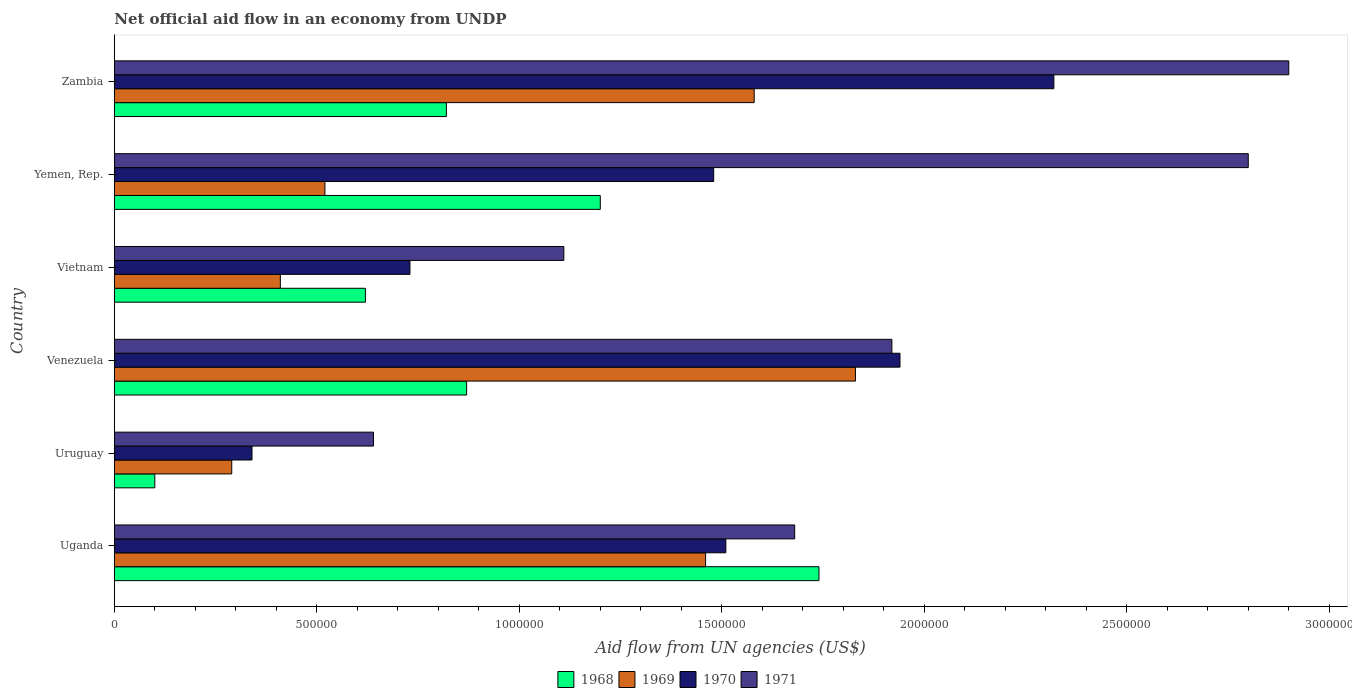How many different coloured bars are there?
Your answer should be very brief. 4. How many groups of bars are there?
Offer a very short reply. 6. Are the number of bars per tick equal to the number of legend labels?
Keep it short and to the point. Yes. Are the number of bars on each tick of the Y-axis equal?
Offer a terse response. Yes. How many bars are there on the 5th tick from the top?
Your response must be concise. 4. How many bars are there on the 3rd tick from the bottom?
Ensure brevity in your answer.  4. What is the label of the 6th group of bars from the top?
Your response must be concise. Uganda. What is the net official aid flow in 1968 in Uganda?
Your answer should be very brief. 1.74e+06. Across all countries, what is the maximum net official aid flow in 1968?
Offer a terse response. 1.74e+06. Across all countries, what is the minimum net official aid flow in 1969?
Provide a succinct answer. 2.90e+05. In which country was the net official aid flow in 1969 maximum?
Offer a terse response. Venezuela. In which country was the net official aid flow in 1970 minimum?
Make the answer very short. Uruguay. What is the total net official aid flow in 1969 in the graph?
Your answer should be very brief. 6.09e+06. What is the difference between the net official aid flow in 1968 in Zambia and the net official aid flow in 1969 in Uganda?
Provide a succinct answer. -6.40e+05. What is the average net official aid flow in 1969 per country?
Offer a very short reply. 1.02e+06. What is the difference between the net official aid flow in 1971 and net official aid flow in 1968 in Uganda?
Make the answer very short. -6.00e+04. In how many countries, is the net official aid flow in 1971 greater than 1700000 US$?
Your answer should be very brief. 3. What is the ratio of the net official aid flow in 1968 in Uganda to that in Vietnam?
Offer a terse response. 2.81. Is the net official aid flow in 1969 in Uruguay less than that in Vietnam?
Provide a short and direct response. Yes. Is the difference between the net official aid flow in 1971 in Uganda and Zambia greater than the difference between the net official aid flow in 1968 in Uganda and Zambia?
Ensure brevity in your answer.  No. What is the difference between the highest and the second highest net official aid flow in 1969?
Ensure brevity in your answer.  2.50e+05. What is the difference between the highest and the lowest net official aid flow in 1969?
Offer a very short reply. 1.54e+06. In how many countries, is the net official aid flow in 1970 greater than the average net official aid flow in 1970 taken over all countries?
Ensure brevity in your answer.  4. What does the 4th bar from the top in Venezuela represents?
Keep it short and to the point. 1968. What does the 4th bar from the bottom in Vietnam represents?
Your answer should be very brief. 1971. Is it the case that in every country, the sum of the net official aid flow in 1971 and net official aid flow in 1970 is greater than the net official aid flow in 1969?
Offer a very short reply. Yes. Are all the bars in the graph horizontal?
Give a very brief answer. Yes. What is the difference between two consecutive major ticks on the X-axis?
Keep it short and to the point. 5.00e+05. Does the graph contain grids?
Provide a succinct answer. No. What is the title of the graph?
Your answer should be very brief. Net official aid flow in an economy from UNDP. What is the label or title of the X-axis?
Make the answer very short. Aid flow from UN agencies (US$). What is the label or title of the Y-axis?
Provide a succinct answer. Country. What is the Aid flow from UN agencies (US$) in 1968 in Uganda?
Offer a very short reply. 1.74e+06. What is the Aid flow from UN agencies (US$) in 1969 in Uganda?
Keep it short and to the point. 1.46e+06. What is the Aid flow from UN agencies (US$) of 1970 in Uganda?
Offer a terse response. 1.51e+06. What is the Aid flow from UN agencies (US$) of 1971 in Uganda?
Offer a very short reply. 1.68e+06. What is the Aid flow from UN agencies (US$) in 1969 in Uruguay?
Your answer should be very brief. 2.90e+05. What is the Aid flow from UN agencies (US$) in 1971 in Uruguay?
Your answer should be very brief. 6.40e+05. What is the Aid flow from UN agencies (US$) in 1968 in Venezuela?
Make the answer very short. 8.70e+05. What is the Aid flow from UN agencies (US$) in 1969 in Venezuela?
Ensure brevity in your answer.  1.83e+06. What is the Aid flow from UN agencies (US$) in 1970 in Venezuela?
Keep it short and to the point. 1.94e+06. What is the Aid flow from UN agencies (US$) in 1971 in Venezuela?
Ensure brevity in your answer.  1.92e+06. What is the Aid flow from UN agencies (US$) of 1968 in Vietnam?
Your response must be concise. 6.20e+05. What is the Aid flow from UN agencies (US$) of 1970 in Vietnam?
Give a very brief answer. 7.30e+05. What is the Aid flow from UN agencies (US$) in 1971 in Vietnam?
Keep it short and to the point. 1.11e+06. What is the Aid flow from UN agencies (US$) of 1968 in Yemen, Rep.?
Keep it short and to the point. 1.20e+06. What is the Aid flow from UN agencies (US$) in 1969 in Yemen, Rep.?
Offer a very short reply. 5.20e+05. What is the Aid flow from UN agencies (US$) of 1970 in Yemen, Rep.?
Provide a succinct answer. 1.48e+06. What is the Aid flow from UN agencies (US$) in 1971 in Yemen, Rep.?
Make the answer very short. 2.80e+06. What is the Aid flow from UN agencies (US$) of 1968 in Zambia?
Your answer should be compact. 8.20e+05. What is the Aid flow from UN agencies (US$) of 1969 in Zambia?
Your response must be concise. 1.58e+06. What is the Aid flow from UN agencies (US$) of 1970 in Zambia?
Provide a succinct answer. 2.32e+06. What is the Aid flow from UN agencies (US$) in 1971 in Zambia?
Give a very brief answer. 2.90e+06. Across all countries, what is the maximum Aid flow from UN agencies (US$) of 1968?
Offer a very short reply. 1.74e+06. Across all countries, what is the maximum Aid flow from UN agencies (US$) of 1969?
Offer a terse response. 1.83e+06. Across all countries, what is the maximum Aid flow from UN agencies (US$) in 1970?
Give a very brief answer. 2.32e+06. Across all countries, what is the maximum Aid flow from UN agencies (US$) in 1971?
Provide a short and direct response. 2.90e+06. Across all countries, what is the minimum Aid flow from UN agencies (US$) in 1968?
Your response must be concise. 1.00e+05. Across all countries, what is the minimum Aid flow from UN agencies (US$) in 1970?
Ensure brevity in your answer.  3.40e+05. Across all countries, what is the minimum Aid flow from UN agencies (US$) in 1971?
Keep it short and to the point. 6.40e+05. What is the total Aid flow from UN agencies (US$) of 1968 in the graph?
Your answer should be compact. 5.35e+06. What is the total Aid flow from UN agencies (US$) of 1969 in the graph?
Give a very brief answer. 6.09e+06. What is the total Aid flow from UN agencies (US$) in 1970 in the graph?
Make the answer very short. 8.32e+06. What is the total Aid flow from UN agencies (US$) in 1971 in the graph?
Your answer should be very brief. 1.10e+07. What is the difference between the Aid flow from UN agencies (US$) in 1968 in Uganda and that in Uruguay?
Your answer should be compact. 1.64e+06. What is the difference between the Aid flow from UN agencies (US$) of 1969 in Uganda and that in Uruguay?
Give a very brief answer. 1.17e+06. What is the difference between the Aid flow from UN agencies (US$) of 1970 in Uganda and that in Uruguay?
Your answer should be compact. 1.17e+06. What is the difference between the Aid flow from UN agencies (US$) in 1971 in Uganda and that in Uruguay?
Make the answer very short. 1.04e+06. What is the difference between the Aid flow from UN agencies (US$) of 1968 in Uganda and that in Venezuela?
Your response must be concise. 8.70e+05. What is the difference between the Aid flow from UN agencies (US$) in 1969 in Uganda and that in Venezuela?
Your answer should be compact. -3.70e+05. What is the difference between the Aid flow from UN agencies (US$) in 1970 in Uganda and that in Venezuela?
Give a very brief answer. -4.30e+05. What is the difference between the Aid flow from UN agencies (US$) of 1971 in Uganda and that in Venezuela?
Make the answer very short. -2.40e+05. What is the difference between the Aid flow from UN agencies (US$) of 1968 in Uganda and that in Vietnam?
Offer a very short reply. 1.12e+06. What is the difference between the Aid flow from UN agencies (US$) in 1969 in Uganda and that in Vietnam?
Offer a terse response. 1.05e+06. What is the difference between the Aid flow from UN agencies (US$) in 1970 in Uganda and that in Vietnam?
Provide a succinct answer. 7.80e+05. What is the difference between the Aid flow from UN agencies (US$) of 1971 in Uganda and that in Vietnam?
Your response must be concise. 5.70e+05. What is the difference between the Aid flow from UN agencies (US$) of 1968 in Uganda and that in Yemen, Rep.?
Offer a terse response. 5.40e+05. What is the difference between the Aid flow from UN agencies (US$) in 1969 in Uganda and that in Yemen, Rep.?
Your response must be concise. 9.40e+05. What is the difference between the Aid flow from UN agencies (US$) in 1971 in Uganda and that in Yemen, Rep.?
Your response must be concise. -1.12e+06. What is the difference between the Aid flow from UN agencies (US$) of 1968 in Uganda and that in Zambia?
Offer a very short reply. 9.20e+05. What is the difference between the Aid flow from UN agencies (US$) in 1969 in Uganda and that in Zambia?
Offer a very short reply. -1.20e+05. What is the difference between the Aid flow from UN agencies (US$) of 1970 in Uganda and that in Zambia?
Your answer should be compact. -8.10e+05. What is the difference between the Aid flow from UN agencies (US$) in 1971 in Uganda and that in Zambia?
Your answer should be very brief. -1.22e+06. What is the difference between the Aid flow from UN agencies (US$) in 1968 in Uruguay and that in Venezuela?
Ensure brevity in your answer.  -7.70e+05. What is the difference between the Aid flow from UN agencies (US$) of 1969 in Uruguay and that in Venezuela?
Your answer should be very brief. -1.54e+06. What is the difference between the Aid flow from UN agencies (US$) of 1970 in Uruguay and that in Venezuela?
Offer a terse response. -1.60e+06. What is the difference between the Aid flow from UN agencies (US$) of 1971 in Uruguay and that in Venezuela?
Provide a short and direct response. -1.28e+06. What is the difference between the Aid flow from UN agencies (US$) of 1968 in Uruguay and that in Vietnam?
Your answer should be very brief. -5.20e+05. What is the difference between the Aid flow from UN agencies (US$) in 1970 in Uruguay and that in Vietnam?
Your answer should be very brief. -3.90e+05. What is the difference between the Aid flow from UN agencies (US$) in 1971 in Uruguay and that in Vietnam?
Provide a succinct answer. -4.70e+05. What is the difference between the Aid flow from UN agencies (US$) in 1968 in Uruguay and that in Yemen, Rep.?
Give a very brief answer. -1.10e+06. What is the difference between the Aid flow from UN agencies (US$) of 1970 in Uruguay and that in Yemen, Rep.?
Your answer should be very brief. -1.14e+06. What is the difference between the Aid flow from UN agencies (US$) of 1971 in Uruguay and that in Yemen, Rep.?
Your answer should be compact. -2.16e+06. What is the difference between the Aid flow from UN agencies (US$) of 1968 in Uruguay and that in Zambia?
Keep it short and to the point. -7.20e+05. What is the difference between the Aid flow from UN agencies (US$) in 1969 in Uruguay and that in Zambia?
Offer a terse response. -1.29e+06. What is the difference between the Aid flow from UN agencies (US$) in 1970 in Uruguay and that in Zambia?
Offer a very short reply. -1.98e+06. What is the difference between the Aid flow from UN agencies (US$) in 1971 in Uruguay and that in Zambia?
Provide a short and direct response. -2.26e+06. What is the difference between the Aid flow from UN agencies (US$) in 1968 in Venezuela and that in Vietnam?
Your answer should be very brief. 2.50e+05. What is the difference between the Aid flow from UN agencies (US$) of 1969 in Venezuela and that in Vietnam?
Give a very brief answer. 1.42e+06. What is the difference between the Aid flow from UN agencies (US$) in 1970 in Venezuela and that in Vietnam?
Make the answer very short. 1.21e+06. What is the difference between the Aid flow from UN agencies (US$) in 1971 in Venezuela and that in Vietnam?
Keep it short and to the point. 8.10e+05. What is the difference between the Aid flow from UN agencies (US$) in 1968 in Venezuela and that in Yemen, Rep.?
Ensure brevity in your answer.  -3.30e+05. What is the difference between the Aid flow from UN agencies (US$) of 1969 in Venezuela and that in Yemen, Rep.?
Your response must be concise. 1.31e+06. What is the difference between the Aid flow from UN agencies (US$) in 1971 in Venezuela and that in Yemen, Rep.?
Provide a short and direct response. -8.80e+05. What is the difference between the Aid flow from UN agencies (US$) of 1968 in Venezuela and that in Zambia?
Offer a terse response. 5.00e+04. What is the difference between the Aid flow from UN agencies (US$) in 1969 in Venezuela and that in Zambia?
Your response must be concise. 2.50e+05. What is the difference between the Aid flow from UN agencies (US$) in 1970 in Venezuela and that in Zambia?
Your answer should be compact. -3.80e+05. What is the difference between the Aid flow from UN agencies (US$) of 1971 in Venezuela and that in Zambia?
Ensure brevity in your answer.  -9.80e+05. What is the difference between the Aid flow from UN agencies (US$) of 1968 in Vietnam and that in Yemen, Rep.?
Your answer should be compact. -5.80e+05. What is the difference between the Aid flow from UN agencies (US$) in 1970 in Vietnam and that in Yemen, Rep.?
Your answer should be compact. -7.50e+05. What is the difference between the Aid flow from UN agencies (US$) of 1971 in Vietnam and that in Yemen, Rep.?
Ensure brevity in your answer.  -1.69e+06. What is the difference between the Aid flow from UN agencies (US$) in 1968 in Vietnam and that in Zambia?
Give a very brief answer. -2.00e+05. What is the difference between the Aid flow from UN agencies (US$) in 1969 in Vietnam and that in Zambia?
Provide a short and direct response. -1.17e+06. What is the difference between the Aid flow from UN agencies (US$) in 1970 in Vietnam and that in Zambia?
Your answer should be very brief. -1.59e+06. What is the difference between the Aid flow from UN agencies (US$) of 1971 in Vietnam and that in Zambia?
Offer a very short reply. -1.79e+06. What is the difference between the Aid flow from UN agencies (US$) in 1969 in Yemen, Rep. and that in Zambia?
Provide a short and direct response. -1.06e+06. What is the difference between the Aid flow from UN agencies (US$) of 1970 in Yemen, Rep. and that in Zambia?
Keep it short and to the point. -8.40e+05. What is the difference between the Aid flow from UN agencies (US$) in 1968 in Uganda and the Aid flow from UN agencies (US$) in 1969 in Uruguay?
Offer a terse response. 1.45e+06. What is the difference between the Aid flow from UN agencies (US$) of 1968 in Uganda and the Aid flow from UN agencies (US$) of 1970 in Uruguay?
Offer a terse response. 1.40e+06. What is the difference between the Aid flow from UN agencies (US$) in 1968 in Uganda and the Aid flow from UN agencies (US$) in 1971 in Uruguay?
Keep it short and to the point. 1.10e+06. What is the difference between the Aid flow from UN agencies (US$) in 1969 in Uganda and the Aid flow from UN agencies (US$) in 1970 in Uruguay?
Provide a short and direct response. 1.12e+06. What is the difference between the Aid flow from UN agencies (US$) in 1969 in Uganda and the Aid flow from UN agencies (US$) in 1971 in Uruguay?
Offer a terse response. 8.20e+05. What is the difference between the Aid flow from UN agencies (US$) in 1970 in Uganda and the Aid flow from UN agencies (US$) in 1971 in Uruguay?
Your answer should be very brief. 8.70e+05. What is the difference between the Aid flow from UN agencies (US$) of 1968 in Uganda and the Aid flow from UN agencies (US$) of 1969 in Venezuela?
Make the answer very short. -9.00e+04. What is the difference between the Aid flow from UN agencies (US$) of 1968 in Uganda and the Aid flow from UN agencies (US$) of 1970 in Venezuela?
Your response must be concise. -2.00e+05. What is the difference between the Aid flow from UN agencies (US$) of 1968 in Uganda and the Aid flow from UN agencies (US$) of 1971 in Venezuela?
Keep it short and to the point. -1.80e+05. What is the difference between the Aid flow from UN agencies (US$) of 1969 in Uganda and the Aid flow from UN agencies (US$) of 1970 in Venezuela?
Provide a succinct answer. -4.80e+05. What is the difference between the Aid flow from UN agencies (US$) in 1969 in Uganda and the Aid flow from UN agencies (US$) in 1971 in Venezuela?
Your answer should be very brief. -4.60e+05. What is the difference between the Aid flow from UN agencies (US$) of 1970 in Uganda and the Aid flow from UN agencies (US$) of 1971 in Venezuela?
Make the answer very short. -4.10e+05. What is the difference between the Aid flow from UN agencies (US$) in 1968 in Uganda and the Aid flow from UN agencies (US$) in 1969 in Vietnam?
Provide a succinct answer. 1.33e+06. What is the difference between the Aid flow from UN agencies (US$) of 1968 in Uganda and the Aid flow from UN agencies (US$) of 1970 in Vietnam?
Your answer should be compact. 1.01e+06. What is the difference between the Aid flow from UN agencies (US$) in 1968 in Uganda and the Aid flow from UN agencies (US$) in 1971 in Vietnam?
Your response must be concise. 6.30e+05. What is the difference between the Aid flow from UN agencies (US$) in 1969 in Uganda and the Aid flow from UN agencies (US$) in 1970 in Vietnam?
Provide a succinct answer. 7.30e+05. What is the difference between the Aid flow from UN agencies (US$) in 1969 in Uganda and the Aid flow from UN agencies (US$) in 1971 in Vietnam?
Keep it short and to the point. 3.50e+05. What is the difference between the Aid flow from UN agencies (US$) of 1968 in Uganda and the Aid flow from UN agencies (US$) of 1969 in Yemen, Rep.?
Ensure brevity in your answer.  1.22e+06. What is the difference between the Aid flow from UN agencies (US$) in 1968 in Uganda and the Aid flow from UN agencies (US$) in 1971 in Yemen, Rep.?
Offer a terse response. -1.06e+06. What is the difference between the Aid flow from UN agencies (US$) of 1969 in Uganda and the Aid flow from UN agencies (US$) of 1971 in Yemen, Rep.?
Provide a short and direct response. -1.34e+06. What is the difference between the Aid flow from UN agencies (US$) of 1970 in Uganda and the Aid flow from UN agencies (US$) of 1971 in Yemen, Rep.?
Make the answer very short. -1.29e+06. What is the difference between the Aid flow from UN agencies (US$) in 1968 in Uganda and the Aid flow from UN agencies (US$) in 1969 in Zambia?
Offer a very short reply. 1.60e+05. What is the difference between the Aid flow from UN agencies (US$) of 1968 in Uganda and the Aid flow from UN agencies (US$) of 1970 in Zambia?
Offer a very short reply. -5.80e+05. What is the difference between the Aid flow from UN agencies (US$) in 1968 in Uganda and the Aid flow from UN agencies (US$) in 1971 in Zambia?
Give a very brief answer. -1.16e+06. What is the difference between the Aid flow from UN agencies (US$) in 1969 in Uganda and the Aid flow from UN agencies (US$) in 1970 in Zambia?
Offer a terse response. -8.60e+05. What is the difference between the Aid flow from UN agencies (US$) of 1969 in Uganda and the Aid flow from UN agencies (US$) of 1971 in Zambia?
Your answer should be very brief. -1.44e+06. What is the difference between the Aid flow from UN agencies (US$) in 1970 in Uganda and the Aid flow from UN agencies (US$) in 1971 in Zambia?
Your answer should be compact. -1.39e+06. What is the difference between the Aid flow from UN agencies (US$) in 1968 in Uruguay and the Aid flow from UN agencies (US$) in 1969 in Venezuela?
Offer a very short reply. -1.73e+06. What is the difference between the Aid flow from UN agencies (US$) of 1968 in Uruguay and the Aid flow from UN agencies (US$) of 1970 in Venezuela?
Offer a terse response. -1.84e+06. What is the difference between the Aid flow from UN agencies (US$) of 1968 in Uruguay and the Aid flow from UN agencies (US$) of 1971 in Venezuela?
Offer a very short reply. -1.82e+06. What is the difference between the Aid flow from UN agencies (US$) in 1969 in Uruguay and the Aid flow from UN agencies (US$) in 1970 in Venezuela?
Make the answer very short. -1.65e+06. What is the difference between the Aid flow from UN agencies (US$) of 1969 in Uruguay and the Aid flow from UN agencies (US$) of 1971 in Venezuela?
Provide a short and direct response. -1.63e+06. What is the difference between the Aid flow from UN agencies (US$) of 1970 in Uruguay and the Aid flow from UN agencies (US$) of 1971 in Venezuela?
Provide a succinct answer. -1.58e+06. What is the difference between the Aid flow from UN agencies (US$) of 1968 in Uruguay and the Aid flow from UN agencies (US$) of 1969 in Vietnam?
Your response must be concise. -3.10e+05. What is the difference between the Aid flow from UN agencies (US$) in 1968 in Uruguay and the Aid flow from UN agencies (US$) in 1970 in Vietnam?
Give a very brief answer. -6.30e+05. What is the difference between the Aid flow from UN agencies (US$) in 1968 in Uruguay and the Aid flow from UN agencies (US$) in 1971 in Vietnam?
Ensure brevity in your answer.  -1.01e+06. What is the difference between the Aid flow from UN agencies (US$) of 1969 in Uruguay and the Aid flow from UN agencies (US$) of 1970 in Vietnam?
Ensure brevity in your answer.  -4.40e+05. What is the difference between the Aid flow from UN agencies (US$) of 1969 in Uruguay and the Aid flow from UN agencies (US$) of 1971 in Vietnam?
Your answer should be compact. -8.20e+05. What is the difference between the Aid flow from UN agencies (US$) in 1970 in Uruguay and the Aid flow from UN agencies (US$) in 1971 in Vietnam?
Give a very brief answer. -7.70e+05. What is the difference between the Aid flow from UN agencies (US$) of 1968 in Uruguay and the Aid flow from UN agencies (US$) of 1969 in Yemen, Rep.?
Make the answer very short. -4.20e+05. What is the difference between the Aid flow from UN agencies (US$) of 1968 in Uruguay and the Aid flow from UN agencies (US$) of 1970 in Yemen, Rep.?
Keep it short and to the point. -1.38e+06. What is the difference between the Aid flow from UN agencies (US$) of 1968 in Uruguay and the Aid flow from UN agencies (US$) of 1971 in Yemen, Rep.?
Offer a terse response. -2.70e+06. What is the difference between the Aid flow from UN agencies (US$) in 1969 in Uruguay and the Aid flow from UN agencies (US$) in 1970 in Yemen, Rep.?
Keep it short and to the point. -1.19e+06. What is the difference between the Aid flow from UN agencies (US$) of 1969 in Uruguay and the Aid flow from UN agencies (US$) of 1971 in Yemen, Rep.?
Give a very brief answer. -2.51e+06. What is the difference between the Aid flow from UN agencies (US$) of 1970 in Uruguay and the Aid flow from UN agencies (US$) of 1971 in Yemen, Rep.?
Offer a very short reply. -2.46e+06. What is the difference between the Aid flow from UN agencies (US$) in 1968 in Uruguay and the Aid flow from UN agencies (US$) in 1969 in Zambia?
Keep it short and to the point. -1.48e+06. What is the difference between the Aid flow from UN agencies (US$) of 1968 in Uruguay and the Aid flow from UN agencies (US$) of 1970 in Zambia?
Give a very brief answer. -2.22e+06. What is the difference between the Aid flow from UN agencies (US$) in 1968 in Uruguay and the Aid flow from UN agencies (US$) in 1971 in Zambia?
Your response must be concise. -2.80e+06. What is the difference between the Aid flow from UN agencies (US$) of 1969 in Uruguay and the Aid flow from UN agencies (US$) of 1970 in Zambia?
Provide a short and direct response. -2.03e+06. What is the difference between the Aid flow from UN agencies (US$) of 1969 in Uruguay and the Aid flow from UN agencies (US$) of 1971 in Zambia?
Make the answer very short. -2.61e+06. What is the difference between the Aid flow from UN agencies (US$) in 1970 in Uruguay and the Aid flow from UN agencies (US$) in 1971 in Zambia?
Make the answer very short. -2.56e+06. What is the difference between the Aid flow from UN agencies (US$) of 1968 in Venezuela and the Aid flow from UN agencies (US$) of 1970 in Vietnam?
Make the answer very short. 1.40e+05. What is the difference between the Aid flow from UN agencies (US$) in 1968 in Venezuela and the Aid flow from UN agencies (US$) in 1971 in Vietnam?
Give a very brief answer. -2.40e+05. What is the difference between the Aid flow from UN agencies (US$) of 1969 in Venezuela and the Aid flow from UN agencies (US$) of 1970 in Vietnam?
Your answer should be compact. 1.10e+06. What is the difference between the Aid flow from UN agencies (US$) of 1969 in Venezuela and the Aid flow from UN agencies (US$) of 1971 in Vietnam?
Provide a short and direct response. 7.20e+05. What is the difference between the Aid flow from UN agencies (US$) of 1970 in Venezuela and the Aid flow from UN agencies (US$) of 1971 in Vietnam?
Keep it short and to the point. 8.30e+05. What is the difference between the Aid flow from UN agencies (US$) of 1968 in Venezuela and the Aid flow from UN agencies (US$) of 1969 in Yemen, Rep.?
Your answer should be very brief. 3.50e+05. What is the difference between the Aid flow from UN agencies (US$) of 1968 in Venezuela and the Aid flow from UN agencies (US$) of 1970 in Yemen, Rep.?
Make the answer very short. -6.10e+05. What is the difference between the Aid flow from UN agencies (US$) of 1968 in Venezuela and the Aid flow from UN agencies (US$) of 1971 in Yemen, Rep.?
Offer a terse response. -1.93e+06. What is the difference between the Aid flow from UN agencies (US$) of 1969 in Venezuela and the Aid flow from UN agencies (US$) of 1970 in Yemen, Rep.?
Offer a very short reply. 3.50e+05. What is the difference between the Aid flow from UN agencies (US$) in 1969 in Venezuela and the Aid flow from UN agencies (US$) in 1971 in Yemen, Rep.?
Your response must be concise. -9.70e+05. What is the difference between the Aid flow from UN agencies (US$) of 1970 in Venezuela and the Aid flow from UN agencies (US$) of 1971 in Yemen, Rep.?
Keep it short and to the point. -8.60e+05. What is the difference between the Aid flow from UN agencies (US$) of 1968 in Venezuela and the Aid flow from UN agencies (US$) of 1969 in Zambia?
Give a very brief answer. -7.10e+05. What is the difference between the Aid flow from UN agencies (US$) of 1968 in Venezuela and the Aid flow from UN agencies (US$) of 1970 in Zambia?
Provide a succinct answer. -1.45e+06. What is the difference between the Aid flow from UN agencies (US$) of 1968 in Venezuela and the Aid flow from UN agencies (US$) of 1971 in Zambia?
Offer a terse response. -2.03e+06. What is the difference between the Aid flow from UN agencies (US$) in 1969 in Venezuela and the Aid flow from UN agencies (US$) in 1970 in Zambia?
Offer a terse response. -4.90e+05. What is the difference between the Aid flow from UN agencies (US$) in 1969 in Venezuela and the Aid flow from UN agencies (US$) in 1971 in Zambia?
Make the answer very short. -1.07e+06. What is the difference between the Aid flow from UN agencies (US$) of 1970 in Venezuela and the Aid flow from UN agencies (US$) of 1971 in Zambia?
Offer a very short reply. -9.60e+05. What is the difference between the Aid flow from UN agencies (US$) of 1968 in Vietnam and the Aid flow from UN agencies (US$) of 1969 in Yemen, Rep.?
Your answer should be compact. 1.00e+05. What is the difference between the Aid flow from UN agencies (US$) of 1968 in Vietnam and the Aid flow from UN agencies (US$) of 1970 in Yemen, Rep.?
Ensure brevity in your answer.  -8.60e+05. What is the difference between the Aid flow from UN agencies (US$) in 1968 in Vietnam and the Aid flow from UN agencies (US$) in 1971 in Yemen, Rep.?
Offer a terse response. -2.18e+06. What is the difference between the Aid flow from UN agencies (US$) of 1969 in Vietnam and the Aid flow from UN agencies (US$) of 1970 in Yemen, Rep.?
Give a very brief answer. -1.07e+06. What is the difference between the Aid flow from UN agencies (US$) in 1969 in Vietnam and the Aid flow from UN agencies (US$) in 1971 in Yemen, Rep.?
Provide a short and direct response. -2.39e+06. What is the difference between the Aid flow from UN agencies (US$) in 1970 in Vietnam and the Aid flow from UN agencies (US$) in 1971 in Yemen, Rep.?
Offer a terse response. -2.07e+06. What is the difference between the Aid flow from UN agencies (US$) of 1968 in Vietnam and the Aid flow from UN agencies (US$) of 1969 in Zambia?
Offer a very short reply. -9.60e+05. What is the difference between the Aid flow from UN agencies (US$) in 1968 in Vietnam and the Aid flow from UN agencies (US$) in 1970 in Zambia?
Your answer should be very brief. -1.70e+06. What is the difference between the Aid flow from UN agencies (US$) of 1968 in Vietnam and the Aid flow from UN agencies (US$) of 1971 in Zambia?
Offer a very short reply. -2.28e+06. What is the difference between the Aid flow from UN agencies (US$) in 1969 in Vietnam and the Aid flow from UN agencies (US$) in 1970 in Zambia?
Offer a very short reply. -1.91e+06. What is the difference between the Aid flow from UN agencies (US$) of 1969 in Vietnam and the Aid flow from UN agencies (US$) of 1971 in Zambia?
Your response must be concise. -2.49e+06. What is the difference between the Aid flow from UN agencies (US$) in 1970 in Vietnam and the Aid flow from UN agencies (US$) in 1971 in Zambia?
Provide a succinct answer. -2.17e+06. What is the difference between the Aid flow from UN agencies (US$) of 1968 in Yemen, Rep. and the Aid flow from UN agencies (US$) of 1969 in Zambia?
Make the answer very short. -3.80e+05. What is the difference between the Aid flow from UN agencies (US$) of 1968 in Yemen, Rep. and the Aid flow from UN agencies (US$) of 1970 in Zambia?
Provide a succinct answer. -1.12e+06. What is the difference between the Aid flow from UN agencies (US$) in 1968 in Yemen, Rep. and the Aid flow from UN agencies (US$) in 1971 in Zambia?
Give a very brief answer. -1.70e+06. What is the difference between the Aid flow from UN agencies (US$) in 1969 in Yemen, Rep. and the Aid flow from UN agencies (US$) in 1970 in Zambia?
Give a very brief answer. -1.80e+06. What is the difference between the Aid flow from UN agencies (US$) in 1969 in Yemen, Rep. and the Aid flow from UN agencies (US$) in 1971 in Zambia?
Keep it short and to the point. -2.38e+06. What is the difference between the Aid flow from UN agencies (US$) of 1970 in Yemen, Rep. and the Aid flow from UN agencies (US$) of 1971 in Zambia?
Offer a terse response. -1.42e+06. What is the average Aid flow from UN agencies (US$) in 1968 per country?
Your answer should be compact. 8.92e+05. What is the average Aid flow from UN agencies (US$) of 1969 per country?
Make the answer very short. 1.02e+06. What is the average Aid flow from UN agencies (US$) of 1970 per country?
Offer a very short reply. 1.39e+06. What is the average Aid flow from UN agencies (US$) of 1971 per country?
Offer a very short reply. 1.84e+06. What is the difference between the Aid flow from UN agencies (US$) of 1968 and Aid flow from UN agencies (US$) of 1970 in Uganda?
Make the answer very short. 2.30e+05. What is the difference between the Aid flow from UN agencies (US$) of 1968 and Aid flow from UN agencies (US$) of 1969 in Uruguay?
Provide a succinct answer. -1.90e+05. What is the difference between the Aid flow from UN agencies (US$) of 1968 and Aid flow from UN agencies (US$) of 1971 in Uruguay?
Provide a short and direct response. -5.40e+05. What is the difference between the Aid flow from UN agencies (US$) of 1969 and Aid flow from UN agencies (US$) of 1970 in Uruguay?
Your response must be concise. -5.00e+04. What is the difference between the Aid flow from UN agencies (US$) in 1969 and Aid flow from UN agencies (US$) in 1971 in Uruguay?
Provide a short and direct response. -3.50e+05. What is the difference between the Aid flow from UN agencies (US$) of 1968 and Aid flow from UN agencies (US$) of 1969 in Venezuela?
Your answer should be very brief. -9.60e+05. What is the difference between the Aid flow from UN agencies (US$) in 1968 and Aid flow from UN agencies (US$) in 1970 in Venezuela?
Make the answer very short. -1.07e+06. What is the difference between the Aid flow from UN agencies (US$) in 1968 and Aid flow from UN agencies (US$) in 1971 in Venezuela?
Make the answer very short. -1.05e+06. What is the difference between the Aid flow from UN agencies (US$) of 1969 and Aid flow from UN agencies (US$) of 1970 in Venezuela?
Ensure brevity in your answer.  -1.10e+05. What is the difference between the Aid flow from UN agencies (US$) of 1970 and Aid flow from UN agencies (US$) of 1971 in Venezuela?
Make the answer very short. 2.00e+04. What is the difference between the Aid flow from UN agencies (US$) in 1968 and Aid flow from UN agencies (US$) in 1971 in Vietnam?
Give a very brief answer. -4.90e+05. What is the difference between the Aid flow from UN agencies (US$) in 1969 and Aid flow from UN agencies (US$) in 1970 in Vietnam?
Your response must be concise. -3.20e+05. What is the difference between the Aid flow from UN agencies (US$) in 1969 and Aid flow from UN agencies (US$) in 1971 in Vietnam?
Keep it short and to the point. -7.00e+05. What is the difference between the Aid flow from UN agencies (US$) in 1970 and Aid flow from UN agencies (US$) in 1971 in Vietnam?
Provide a short and direct response. -3.80e+05. What is the difference between the Aid flow from UN agencies (US$) of 1968 and Aid flow from UN agencies (US$) of 1969 in Yemen, Rep.?
Keep it short and to the point. 6.80e+05. What is the difference between the Aid flow from UN agencies (US$) in 1968 and Aid flow from UN agencies (US$) in 1970 in Yemen, Rep.?
Your response must be concise. -2.80e+05. What is the difference between the Aid flow from UN agencies (US$) of 1968 and Aid flow from UN agencies (US$) of 1971 in Yemen, Rep.?
Offer a terse response. -1.60e+06. What is the difference between the Aid flow from UN agencies (US$) of 1969 and Aid flow from UN agencies (US$) of 1970 in Yemen, Rep.?
Provide a short and direct response. -9.60e+05. What is the difference between the Aid flow from UN agencies (US$) of 1969 and Aid flow from UN agencies (US$) of 1971 in Yemen, Rep.?
Your response must be concise. -2.28e+06. What is the difference between the Aid flow from UN agencies (US$) of 1970 and Aid flow from UN agencies (US$) of 1971 in Yemen, Rep.?
Keep it short and to the point. -1.32e+06. What is the difference between the Aid flow from UN agencies (US$) of 1968 and Aid flow from UN agencies (US$) of 1969 in Zambia?
Give a very brief answer. -7.60e+05. What is the difference between the Aid flow from UN agencies (US$) in 1968 and Aid flow from UN agencies (US$) in 1970 in Zambia?
Give a very brief answer. -1.50e+06. What is the difference between the Aid flow from UN agencies (US$) in 1968 and Aid flow from UN agencies (US$) in 1971 in Zambia?
Your answer should be compact. -2.08e+06. What is the difference between the Aid flow from UN agencies (US$) in 1969 and Aid flow from UN agencies (US$) in 1970 in Zambia?
Ensure brevity in your answer.  -7.40e+05. What is the difference between the Aid flow from UN agencies (US$) in 1969 and Aid flow from UN agencies (US$) in 1971 in Zambia?
Provide a short and direct response. -1.32e+06. What is the difference between the Aid flow from UN agencies (US$) of 1970 and Aid flow from UN agencies (US$) of 1971 in Zambia?
Provide a short and direct response. -5.80e+05. What is the ratio of the Aid flow from UN agencies (US$) in 1969 in Uganda to that in Uruguay?
Keep it short and to the point. 5.03. What is the ratio of the Aid flow from UN agencies (US$) in 1970 in Uganda to that in Uruguay?
Ensure brevity in your answer.  4.44. What is the ratio of the Aid flow from UN agencies (US$) in 1971 in Uganda to that in Uruguay?
Offer a terse response. 2.62. What is the ratio of the Aid flow from UN agencies (US$) of 1968 in Uganda to that in Venezuela?
Offer a terse response. 2. What is the ratio of the Aid flow from UN agencies (US$) in 1969 in Uganda to that in Venezuela?
Provide a succinct answer. 0.8. What is the ratio of the Aid flow from UN agencies (US$) in 1970 in Uganda to that in Venezuela?
Your answer should be very brief. 0.78. What is the ratio of the Aid flow from UN agencies (US$) of 1971 in Uganda to that in Venezuela?
Offer a terse response. 0.88. What is the ratio of the Aid flow from UN agencies (US$) of 1968 in Uganda to that in Vietnam?
Make the answer very short. 2.81. What is the ratio of the Aid flow from UN agencies (US$) in 1969 in Uganda to that in Vietnam?
Your answer should be very brief. 3.56. What is the ratio of the Aid flow from UN agencies (US$) in 1970 in Uganda to that in Vietnam?
Provide a short and direct response. 2.07. What is the ratio of the Aid flow from UN agencies (US$) of 1971 in Uganda to that in Vietnam?
Keep it short and to the point. 1.51. What is the ratio of the Aid flow from UN agencies (US$) in 1968 in Uganda to that in Yemen, Rep.?
Offer a terse response. 1.45. What is the ratio of the Aid flow from UN agencies (US$) in 1969 in Uganda to that in Yemen, Rep.?
Your answer should be very brief. 2.81. What is the ratio of the Aid flow from UN agencies (US$) of 1970 in Uganda to that in Yemen, Rep.?
Provide a short and direct response. 1.02. What is the ratio of the Aid flow from UN agencies (US$) of 1971 in Uganda to that in Yemen, Rep.?
Ensure brevity in your answer.  0.6. What is the ratio of the Aid flow from UN agencies (US$) in 1968 in Uganda to that in Zambia?
Make the answer very short. 2.12. What is the ratio of the Aid flow from UN agencies (US$) of 1969 in Uganda to that in Zambia?
Ensure brevity in your answer.  0.92. What is the ratio of the Aid flow from UN agencies (US$) in 1970 in Uganda to that in Zambia?
Provide a short and direct response. 0.65. What is the ratio of the Aid flow from UN agencies (US$) of 1971 in Uganda to that in Zambia?
Keep it short and to the point. 0.58. What is the ratio of the Aid flow from UN agencies (US$) in 1968 in Uruguay to that in Venezuela?
Ensure brevity in your answer.  0.11. What is the ratio of the Aid flow from UN agencies (US$) of 1969 in Uruguay to that in Venezuela?
Give a very brief answer. 0.16. What is the ratio of the Aid flow from UN agencies (US$) in 1970 in Uruguay to that in Venezuela?
Ensure brevity in your answer.  0.18. What is the ratio of the Aid flow from UN agencies (US$) in 1968 in Uruguay to that in Vietnam?
Make the answer very short. 0.16. What is the ratio of the Aid flow from UN agencies (US$) of 1969 in Uruguay to that in Vietnam?
Offer a terse response. 0.71. What is the ratio of the Aid flow from UN agencies (US$) of 1970 in Uruguay to that in Vietnam?
Keep it short and to the point. 0.47. What is the ratio of the Aid flow from UN agencies (US$) of 1971 in Uruguay to that in Vietnam?
Offer a terse response. 0.58. What is the ratio of the Aid flow from UN agencies (US$) in 1968 in Uruguay to that in Yemen, Rep.?
Ensure brevity in your answer.  0.08. What is the ratio of the Aid flow from UN agencies (US$) in 1969 in Uruguay to that in Yemen, Rep.?
Provide a short and direct response. 0.56. What is the ratio of the Aid flow from UN agencies (US$) of 1970 in Uruguay to that in Yemen, Rep.?
Ensure brevity in your answer.  0.23. What is the ratio of the Aid flow from UN agencies (US$) in 1971 in Uruguay to that in Yemen, Rep.?
Provide a short and direct response. 0.23. What is the ratio of the Aid flow from UN agencies (US$) in 1968 in Uruguay to that in Zambia?
Your answer should be compact. 0.12. What is the ratio of the Aid flow from UN agencies (US$) in 1969 in Uruguay to that in Zambia?
Keep it short and to the point. 0.18. What is the ratio of the Aid flow from UN agencies (US$) of 1970 in Uruguay to that in Zambia?
Provide a short and direct response. 0.15. What is the ratio of the Aid flow from UN agencies (US$) of 1971 in Uruguay to that in Zambia?
Give a very brief answer. 0.22. What is the ratio of the Aid flow from UN agencies (US$) in 1968 in Venezuela to that in Vietnam?
Offer a very short reply. 1.4. What is the ratio of the Aid flow from UN agencies (US$) of 1969 in Venezuela to that in Vietnam?
Offer a very short reply. 4.46. What is the ratio of the Aid flow from UN agencies (US$) of 1970 in Venezuela to that in Vietnam?
Your response must be concise. 2.66. What is the ratio of the Aid flow from UN agencies (US$) in 1971 in Venezuela to that in Vietnam?
Make the answer very short. 1.73. What is the ratio of the Aid flow from UN agencies (US$) in 1968 in Venezuela to that in Yemen, Rep.?
Your answer should be very brief. 0.72. What is the ratio of the Aid flow from UN agencies (US$) of 1969 in Venezuela to that in Yemen, Rep.?
Ensure brevity in your answer.  3.52. What is the ratio of the Aid flow from UN agencies (US$) of 1970 in Venezuela to that in Yemen, Rep.?
Your answer should be compact. 1.31. What is the ratio of the Aid flow from UN agencies (US$) in 1971 in Venezuela to that in Yemen, Rep.?
Offer a terse response. 0.69. What is the ratio of the Aid flow from UN agencies (US$) in 1968 in Venezuela to that in Zambia?
Offer a very short reply. 1.06. What is the ratio of the Aid flow from UN agencies (US$) in 1969 in Venezuela to that in Zambia?
Give a very brief answer. 1.16. What is the ratio of the Aid flow from UN agencies (US$) in 1970 in Venezuela to that in Zambia?
Keep it short and to the point. 0.84. What is the ratio of the Aid flow from UN agencies (US$) of 1971 in Venezuela to that in Zambia?
Give a very brief answer. 0.66. What is the ratio of the Aid flow from UN agencies (US$) of 1968 in Vietnam to that in Yemen, Rep.?
Your response must be concise. 0.52. What is the ratio of the Aid flow from UN agencies (US$) of 1969 in Vietnam to that in Yemen, Rep.?
Provide a succinct answer. 0.79. What is the ratio of the Aid flow from UN agencies (US$) of 1970 in Vietnam to that in Yemen, Rep.?
Keep it short and to the point. 0.49. What is the ratio of the Aid flow from UN agencies (US$) in 1971 in Vietnam to that in Yemen, Rep.?
Offer a terse response. 0.4. What is the ratio of the Aid flow from UN agencies (US$) of 1968 in Vietnam to that in Zambia?
Your answer should be compact. 0.76. What is the ratio of the Aid flow from UN agencies (US$) in 1969 in Vietnam to that in Zambia?
Your answer should be very brief. 0.26. What is the ratio of the Aid flow from UN agencies (US$) of 1970 in Vietnam to that in Zambia?
Provide a succinct answer. 0.31. What is the ratio of the Aid flow from UN agencies (US$) in 1971 in Vietnam to that in Zambia?
Ensure brevity in your answer.  0.38. What is the ratio of the Aid flow from UN agencies (US$) in 1968 in Yemen, Rep. to that in Zambia?
Keep it short and to the point. 1.46. What is the ratio of the Aid flow from UN agencies (US$) of 1969 in Yemen, Rep. to that in Zambia?
Give a very brief answer. 0.33. What is the ratio of the Aid flow from UN agencies (US$) in 1970 in Yemen, Rep. to that in Zambia?
Your answer should be compact. 0.64. What is the ratio of the Aid flow from UN agencies (US$) in 1971 in Yemen, Rep. to that in Zambia?
Make the answer very short. 0.97. What is the difference between the highest and the second highest Aid flow from UN agencies (US$) in 1968?
Your answer should be very brief. 5.40e+05. What is the difference between the highest and the second highest Aid flow from UN agencies (US$) of 1969?
Ensure brevity in your answer.  2.50e+05. What is the difference between the highest and the lowest Aid flow from UN agencies (US$) in 1968?
Offer a very short reply. 1.64e+06. What is the difference between the highest and the lowest Aid flow from UN agencies (US$) in 1969?
Ensure brevity in your answer.  1.54e+06. What is the difference between the highest and the lowest Aid flow from UN agencies (US$) in 1970?
Your answer should be compact. 1.98e+06. What is the difference between the highest and the lowest Aid flow from UN agencies (US$) of 1971?
Give a very brief answer. 2.26e+06. 